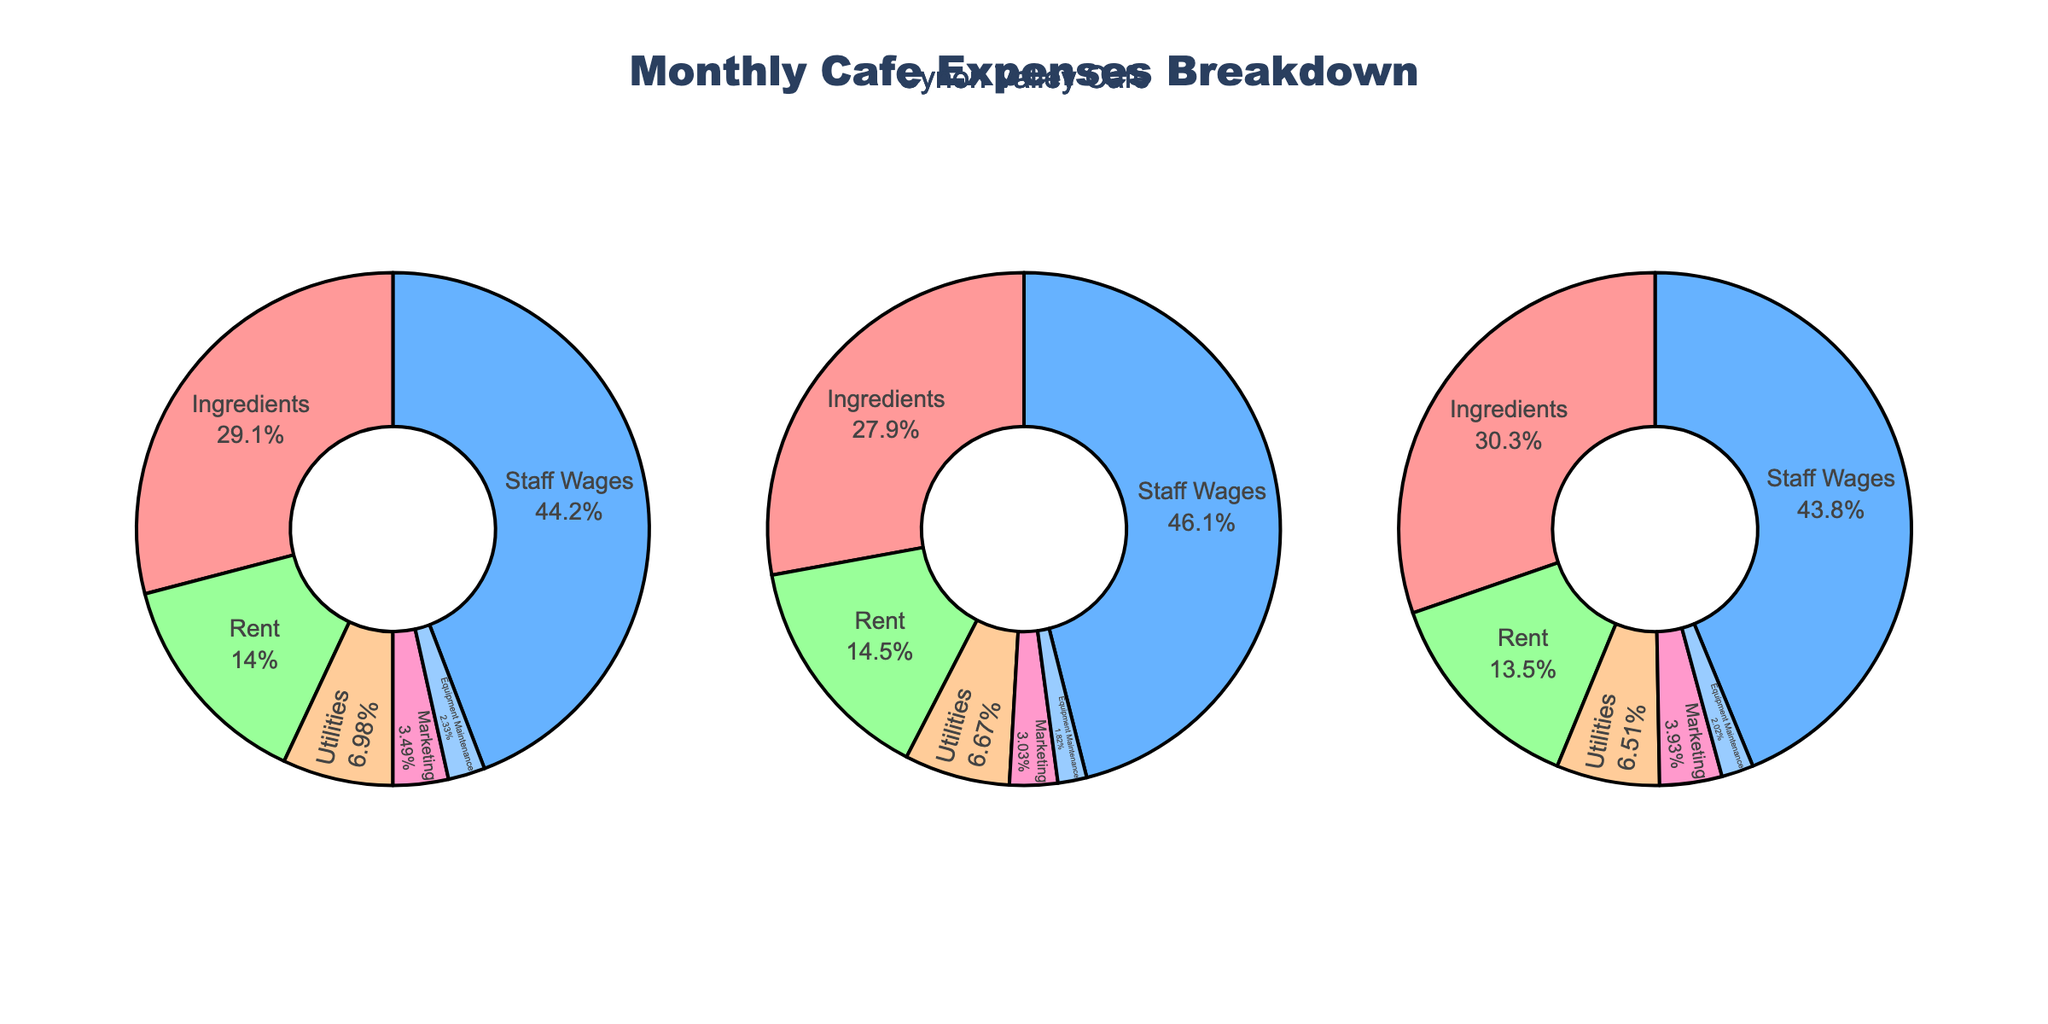What's the title of the figure? The title is located at the top of the plot, and it is "Species Abundance vs Wind Farm Distance."
Answer: Species Abundance vs Wind Farm Distance Which habitat shows the highest abundance of a species at 5.0 km from the wind farm? The Shrubland habitat shows the highest abundance, specifically for the Jackrabbit species, with an abundance of 28.
Answer: Shrubland How many species are observed in the Forest Edge habitat, and what are their names? The legend and subplot titles indicate two species in the Forest Edge habitat: Red-tailed Hawk and Mule Deer.
Answer: Two species: Red-tailed Hawk and Mule Deer What is the pattern of abundance change for Mule Deer in the Forest Edge habitat as the wind farm distance increases? In the Forest Edge habitat, the Mule Deer abundance increases consistently from 7 at 0.5 km, to 12 at 2.0 km, to 16 at 5.0 km.
Answer: Increases consistently Which species has the least abundance at 0.5 km distance from the wind farm across all habitats? By examining all three subplots, Red-tailed Hawk in the Forest Edge habitat has the least abundance of 3 at 0.5 km.
Answer: Red-tailed Hawk Compare the abundance of Meadowlark and Pronghorn at 2.0 km in the Grassland habitat. Which species is more abundant? In the Grassland subplot, Meadowlark has an abundance of 18, while Pronghorn has an abundance of 8 at 2.0 km. Meadowlark is more abundant.
Answer: Meadowlark What’s the overall trend observed for Sage Grouse in the Shrubland habitat as the distance from the wind farm increases? In the Shrubland subplot, Sage Grouse abundance increases steadily from 7 at 0.5 km, to 13 at 2.0 km, to 19 at 5.0 km.
Answer: Increases steadily What is the difference in abundance of Jackrabbit and Sage Grouse at 0.5 km in the Shrubland habitat? In the Shrubland subplot at 0.5 km, Jackrabbit has an abundance of 15 and Sage Grouse has an abundance of 7. The difference is 15 - 7 = 8.
Answer: 8 What is the average abundance of the Red-tailed Hawk species across all distances in the Forest Edge habitat? The Red-tailed Hawk abundance values at 0.5 km, 2.0 km, and 5.0 km are 3, 6, and 9 respectively. The average is (3 + 6 + 9) / 3 = 18 / 3 = 6.
Answer: 6 